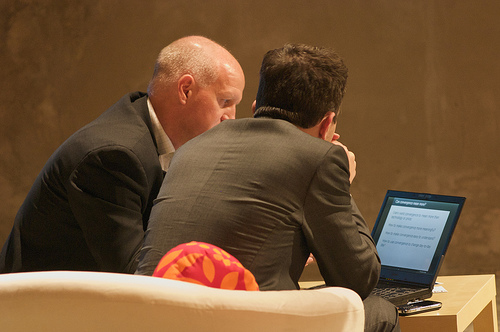How many cushions are in the photo? 1 